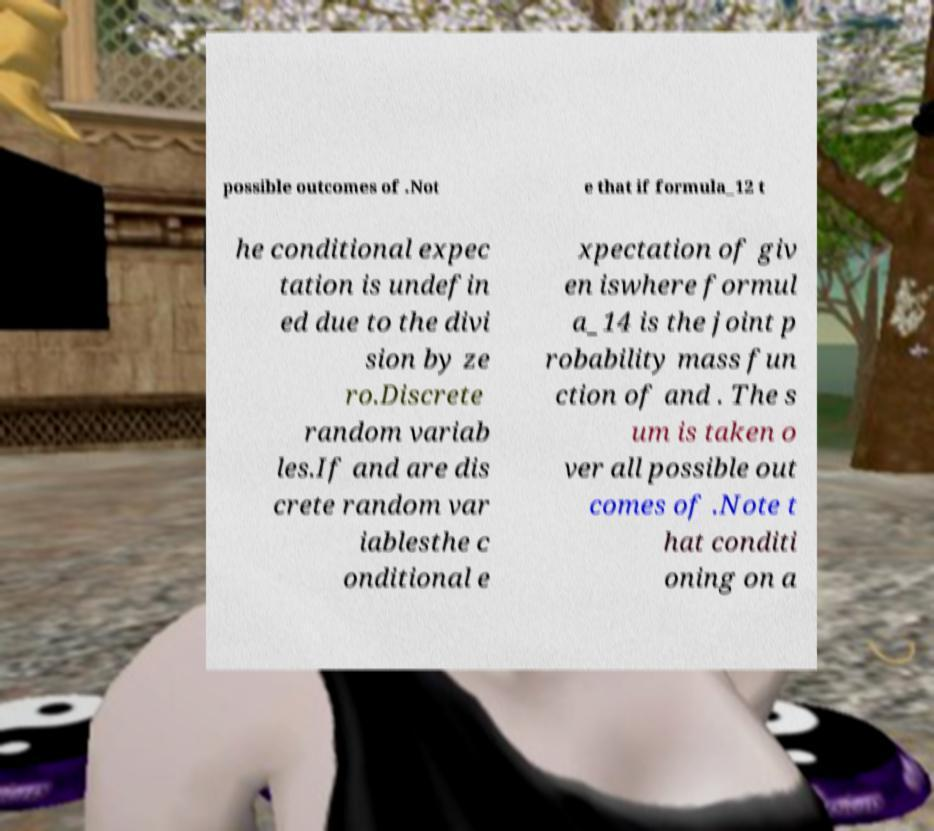Could you extract and type out the text from this image? possible outcomes of .Not e that if formula_12 t he conditional expec tation is undefin ed due to the divi sion by ze ro.Discrete random variab les.If and are dis crete random var iablesthe c onditional e xpectation of giv en iswhere formul a_14 is the joint p robability mass fun ction of and . The s um is taken o ver all possible out comes of .Note t hat conditi oning on a 